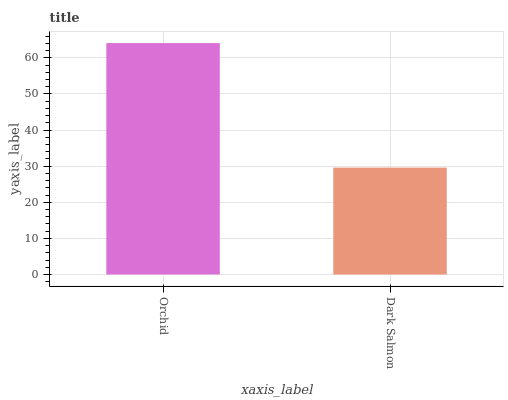Is Dark Salmon the minimum?
Answer yes or no. Yes. Is Orchid the maximum?
Answer yes or no. Yes. Is Dark Salmon the maximum?
Answer yes or no. No. Is Orchid greater than Dark Salmon?
Answer yes or no. Yes. Is Dark Salmon less than Orchid?
Answer yes or no. Yes. Is Dark Salmon greater than Orchid?
Answer yes or no. No. Is Orchid less than Dark Salmon?
Answer yes or no. No. Is Orchid the high median?
Answer yes or no. Yes. Is Dark Salmon the low median?
Answer yes or no. Yes. Is Dark Salmon the high median?
Answer yes or no. No. Is Orchid the low median?
Answer yes or no. No. 